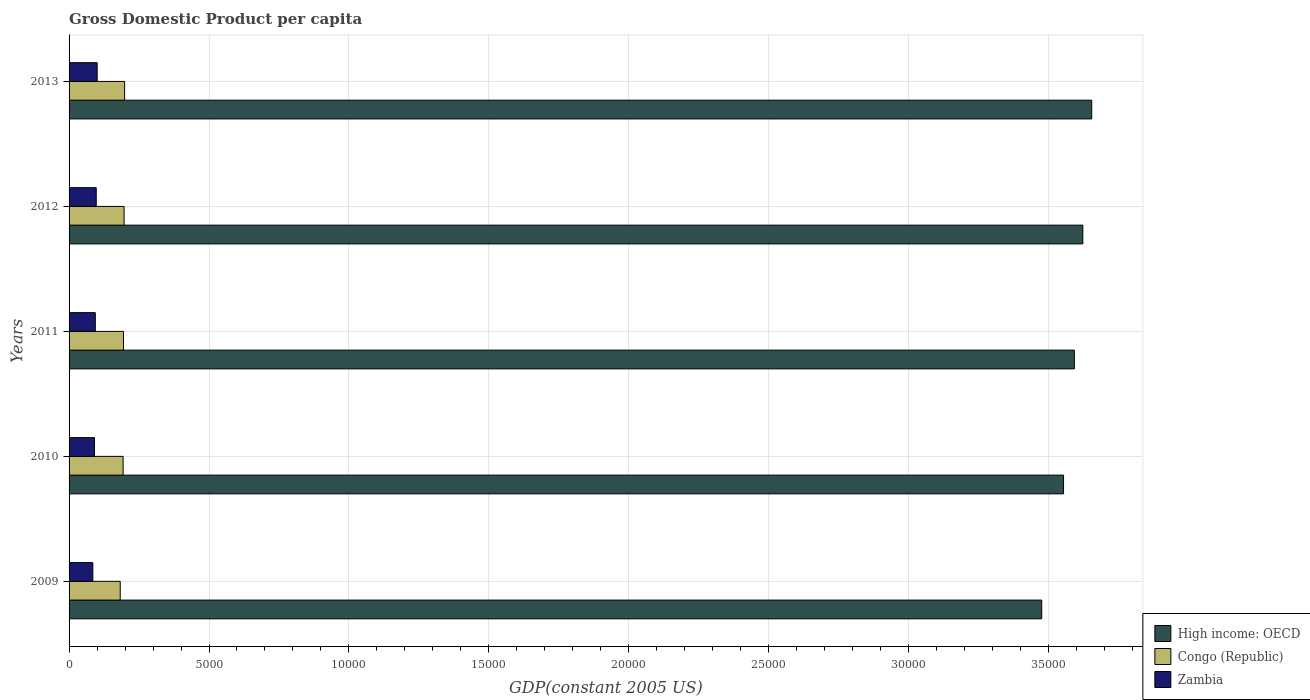How many different coloured bars are there?
Give a very brief answer. 3. How many groups of bars are there?
Keep it short and to the point. 5. Are the number of bars per tick equal to the number of legend labels?
Your answer should be compact. Yes. Are the number of bars on each tick of the Y-axis equal?
Give a very brief answer. Yes. What is the label of the 1st group of bars from the top?
Your answer should be compact. 2013. In how many cases, is the number of bars for a given year not equal to the number of legend labels?
Give a very brief answer. 0. What is the GDP per capita in Zambia in 2010?
Provide a succinct answer. 908.75. Across all years, what is the maximum GDP per capita in Congo (Republic)?
Offer a very short reply. 1984.36. Across all years, what is the minimum GDP per capita in Congo (Republic)?
Your answer should be very brief. 1827.67. In which year was the GDP per capita in Congo (Republic) maximum?
Provide a succinct answer. 2013. In which year was the GDP per capita in Zambia minimum?
Offer a very short reply. 2009. What is the total GDP per capita in High income: OECD in the graph?
Your answer should be very brief. 1.79e+05. What is the difference between the GDP per capita in Zambia in 2010 and that in 2013?
Make the answer very short. -95.97. What is the difference between the GDP per capita in High income: OECD in 2009 and the GDP per capita in Zambia in 2012?
Make the answer very short. 3.38e+04. What is the average GDP per capita in High income: OECD per year?
Provide a short and direct response. 3.58e+04. In the year 2013, what is the difference between the GDP per capita in Zambia and GDP per capita in Congo (Republic)?
Give a very brief answer. -979.64. What is the ratio of the GDP per capita in High income: OECD in 2010 to that in 2011?
Offer a terse response. 0.99. Is the difference between the GDP per capita in Zambia in 2011 and 2012 greater than the difference between the GDP per capita in Congo (Republic) in 2011 and 2012?
Your response must be concise. No. What is the difference between the highest and the second highest GDP per capita in Zambia?
Offer a terse response. 33.95. What is the difference between the highest and the lowest GDP per capita in High income: OECD?
Your answer should be compact. 1786.7. In how many years, is the GDP per capita in High income: OECD greater than the average GDP per capita in High income: OECD taken over all years?
Offer a very short reply. 3. What does the 3rd bar from the top in 2011 represents?
Your answer should be very brief. High income: OECD. What does the 1st bar from the bottom in 2011 represents?
Your answer should be compact. High income: OECD. Is it the case that in every year, the sum of the GDP per capita in High income: OECD and GDP per capita in Congo (Republic) is greater than the GDP per capita in Zambia?
Provide a short and direct response. Yes. How many bars are there?
Provide a short and direct response. 15. Are all the bars in the graph horizontal?
Your response must be concise. Yes. What is the difference between two consecutive major ticks on the X-axis?
Your response must be concise. 5000. Are the values on the major ticks of X-axis written in scientific E-notation?
Ensure brevity in your answer.  No. Does the graph contain any zero values?
Offer a terse response. No. Where does the legend appear in the graph?
Give a very brief answer. Bottom right. How many legend labels are there?
Your answer should be compact. 3. How are the legend labels stacked?
Your answer should be compact. Vertical. What is the title of the graph?
Provide a succinct answer. Gross Domestic Product per capita. What is the label or title of the X-axis?
Ensure brevity in your answer.  GDP(constant 2005 US). What is the label or title of the Y-axis?
Give a very brief answer. Years. What is the GDP(constant 2005 US) of High income: OECD in 2009?
Offer a very short reply. 3.48e+04. What is the GDP(constant 2005 US) of Congo (Republic) in 2009?
Ensure brevity in your answer.  1827.67. What is the GDP(constant 2005 US) of Zambia in 2009?
Provide a succinct answer. 848.88. What is the GDP(constant 2005 US) of High income: OECD in 2010?
Make the answer very short. 3.55e+04. What is the GDP(constant 2005 US) of Congo (Republic) in 2010?
Keep it short and to the point. 1931.26. What is the GDP(constant 2005 US) of Zambia in 2010?
Your answer should be compact. 908.75. What is the GDP(constant 2005 US) of High income: OECD in 2011?
Keep it short and to the point. 3.59e+04. What is the GDP(constant 2005 US) in Congo (Republic) in 2011?
Offer a very short reply. 1944.08. What is the GDP(constant 2005 US) of Zambia in 2011?
Provide a short and direct response. 937.64. What is the GDP(constant 2005 US) of High income: OECD in 2012?
Your answer should be compact. 3.62e+04. What is the GDP(constant 2005 US) in Congo (Republic) in 2012?
Provide a succinct answer. 1966.76. What is the GDP(constant 2005 US) of Zambia in 2012?
Give a very brief answer. 970.77. What is the GDP(constant 2005 US) in High income: OECD in 2013?
Keep it short and to the point. 3.65e+04. What is the GDP(constant 2005 US) of Congo (Republic) in 2013?
Your answer should be very brief. 1984.36. What is the GDP(constant 2005 US) in Zambia in 2013?
Your answer should be compact. 1004.71. Across all years, what is the maximum GDP(constant 2005 US) in High income: OECD?
Offer a terse response. 3.65e+04. Across all years, what is the maximum GDP(constant 2005 US) of Congo (Republic)?
Make the answer very short. 1984.36. Across all years, what is the maximum GDP(constant 2005 US) of Zambia?
Offer a terse response. 1004.71. Across all years, what is the minimum GDP(constant 2005 US) of High income: OECD?
Your answer should be compact. 3.48e+04. Across all years, what is the minimum GDP(constant 2005 US) of Congo (Republic)?
Your answer should be very brief. 1827.67. Across all years, what is the minimum GDP(constant 2005 US) of Zambia?
Provide a short and direct response. 848.88. What is the total GDP(constant 2005 US) in High income: OECD in the graph?
Provide a succinct answer. 1.79e+05. What is the total GDP(constant 2005 US) of Congo (Republic) in the graph?
Your answer should be very brief. 9654.13. What is the total GDP(constant 2005 US) of Zambia in the graph?
Provide a succinct answer. 4670.75. What is the difference between the GDP(constant 2005 US) in High income: OECD in 2009 and that in 2010?
Your answer should be very brief. -780.06. What is the difference between the GDP(constant 2005 US) of Congo (Republic) in 2009 and that in 2010?
Offer a very short reply. -103.59. What is the difference between the GDP(constant 2005 US) in Zambia in 2009 and that in 2010?
Give a very brief answer. -59.86. What is the difference between the GDP(constant 2005 US) of High income: OECD in 2009 and that in 2011?
Your answer should be very brief. -1165.33. What is the difference between the GDP(constant 2005 US) in Congo (Republic) in 2009 and that in 2011?
Your response must be concise. -116.41. What is the difference between the GDP(constant 2005 US) in Zambia in 2009 and that in 2011?
Offer a very short reply. -88.76. What is the difference between the GDP(constant 2005 US) of High income: OECD in 2009 and that in 2012?
Make the answer very short. -1469.18. What is the difference between the GDP(constant 2005 US) in Congo (Republic) in 2009 and that in 2012?
Give a very brief answer. -139.09. What is the difference between the GDP(constant 2005 US) of Zambia in 2009 and that in 2012?
Provide a succinct answer. -121.88. What is the difference between the GDP(constant 2005 US) of High income: OECD in 2009 and that in 2013?
Provide a short and direct response. -1786.7. What is the difference between the GDP(constant 2005 US) in Congo (Republic) in 2009 and that in 2013?
Offer a terse response. -156.69. What is the difference between the GDP(constant 2005 US) of Zambia in 2009 and that in 2013?
Provide a short and direct response. -155.83. What is the difference between the GDP(constant 2005 US) in High income: OECD in 2010 and that in 2011?
Make the answer very short. -385.27. What is the difference between the GDP(constant 2005 US) of Congo (Republic) in 2010 and that in 2011?
Keep it short and to the point. -12.82. What is the difference between the GDP(constant 2005 US) in Zambia in 2010 and that in 2011?
Provide a succinct answer. -28.89. What is the difference between the GDP(constant 2005 US) of High income: OECD in 2010 and that in 2012?
Offer a terse response. -689.12. What is the difference between the GDP(constant 2005 US) in Congo (Republic) in 2010 and that in 2012?
Your answer should be very brief. -35.49. What is the difference between the GDP(constant 2005 US) of Zambia in 2010 and that in 2012?
Your answer should be very brief. -62.02. What is the difference between the GDP(constant 2005 US) in High income: OECD in 2010 and that in 2013?
Provide a short and direct response. -1006.65. What is the difference between the GDP(constant 2005 US) of Congo (Republic) in 2010 and that in 2013?
Your answer should be compact. -53.09. What is the difference between the GDP(constant 2005 US) of Zambia in 2010 and that in 2013?
Your answer should be very brief. -95.97. What is the difference between the GDP(constant 2005 US) of High income: OECD in 2011 and that in 2012?
Provide a short and direct response. -303.85. What is the difference between the GDP(constant 2005 US) of Congo (Republic) in 2011 and that in 2012?
Provide a short and direct response. -22.67. What is the difference between the GDP(constant 2005 US) in Zambia in 2011 and that in 2012?
Provide a succinct answer. -33.12. What is the difference between the GDP(constant 2005 US) of High income: OECD in 2011 and that in 2013?
Offer a terse response. -621.37. What is the difference between the GDP(constant 2005 US) in Congo (Republic) in 2011 and that in 2013?
Make the answer very short. -40.28. What is the difference between the GDP(constant 2005 US) of Zambia in 2011 and that in 2013?
Provide a succinct answer. -67.07. What is the difference between the GDP(constant 2005 US) in High income: OECD in 2012 and that in 2013?
Provide a succinct answer. -317.52. What is the difference between the GDP(constant 2005 US) of Congo (Republic) in 2012 and that in 2013?
Provide a succinct answer. -17.6. What is the difference between the GDP(constant 2005 US) in Zambia in 2012 and that in 2013?
Provide a succinct answer. -33.95. What is the difference between the GDP(constant 2005 US) in High income: OECD in 2009 and the GDP(constant 2005 US) in Congo (Republic) in 2010?
Your answer should be compact. 3.28e+04. What is the difference between the GDP(constant 2005 US) of High income: OECD in 2009 and the GDP(constant 2005 US) of Zambia in 2010?
Provide a short and direct response. 3.38e+04. What is the difference between the GDP(constant 2005 US) in Congo (Republic) in 2009 and the GDP(constant 2005 US) in Zambia in 2010?
Ensure brevity in your answer.  918.92. What is the difference between the GDP(constant 2005 US) in High income: OECD in 2009 and the GDP(constant 2005 US) in Congo (Republic) in 2011?
Provide a short and direct response. 3.28e+04. What is the difference between the GDP(constant 2005 US) in High income: OECD in 2009 and the GDP(constant 2005 US) in Zambia in 2011?
Make the answer very short. 3.38e+04. What is the difference between the GDP(constant 2005 US) of Congo (Republic) in 2009 and the GDP(constant 2005 US) of Zambia in 2011?
Offer a terse response. 890.03. What is the difference between the GDP(constant 2005 US) of High income: OECD in 2009 and the GDP(constant 2005 US) of Congo (Republic) in 2012?
Your answer should be very brief. 3.28e+04. What is the difference between the GDP(constant 2005 US) of High income: OECD in 2009 and the GDP(constant 2005 US) of Zambia in 2012?
Offer a terse response. 3.38e+04. What is the difference between the GDP(constant 2005 US) in Congo (Republic) in 2009 and the GDP(constant 2005 US) in Zambia in 2012?
Offer a terse response. 856.9. What is the difference between the GDP(constant 2005 US) in High income: OECD in 2009 and the GDP(constant 2005 US) in Congo (Republic) in 2013?
Your answer should be compact. 3.28e+04. What is the difference between the GDP(constant 2005 US) in High income: OECD in 2009 and the GDP(constant 2005 US) in Zambia in 2013?
Your response must be concise. 3.37e+04. What is the difference between the GDP(constant 2005 US) in Congo (Republic) in 2009 and the GDP(constant 2005 US) in Zambia in 2013?
Make the answer very short. 822.96. What is the difference between the GDP(constant 2005 US) of High income: OECD in 2010 and the GDP(constant 2005 US) of Congo (Republic) in 2011?
Your answer should be compact. 3.36e+04. What is the difference between the GDP(constant 2005 US) in High income: OECD in 2010 and the GDP(constant 2005 US) in Zambia in 2011?
Offer a terse response. 3.46e+04. What is the difference between the GDP(constant 2005 US) of Congo (Republic) in 2010 and the GDP(constant 2005 US) of Zambia in 2011?
Your answer should be very brief. 993.62. What is the difference between the GDP(constant 2005 US) in High income: OECD in 2010 and the GDP(constant 2005 US) in Congo (Republic) in 2012?
Your answer should be very brief. 3.36e+04. What is the difference between the GDP(constant 2005 US) in High income: OECD in 2010 and the GDP(constant 2005 US) in Zambia in 2012?
Your answer should be compact. 3.46e+04. What is the difference between the GDP(constant 2005 US) in Congo (Republic) in 2010 and the GDP(constant 2005 US) in Zambia in 2012?
Make the answer very short. 960.5. What is the difference between the GDP(constant 2005 US) of High income: OECD in 2010 and the GDP(constant 2005 US) of Congo (Republic) in 2013?
Offer a very short reply. 3.35e+04. What is the difference between the GDP(constant 2005 US) of High income: OECD in 2010 and the GDP(constant 2005 US) of Zambia in 2013?
Make the answer very short. 3.45e+04. What is the difference between the GDP(constant 2005 US) of Congo (Republic) in 2010 and the GDP(constant 2005 US) of Zambia in 2013?
Offer a terse response. 926.55. What is the difference between the GDP(constant 2005 US) in High income: OECD in 2011 and the GDP(constant 2005 US) in Congo (Republic) in 2012?
Keep it short and to the point. 3.40e+04. What is the difference between the GDP(constant 2005 US) of High income: OECD in 2011 and the GDP(constant 2005 US) of Zambia in 2012?
Your answer should be very brief. 3.49e+04. What is the difference between the GDP(constant 2005 US) in Congo (Republic) in 2011 and the GDP(constant 2005 US) in Zambia in 2012?
Give a very brief answer. 973.32. What is the difference between the GDP(constant 2005 US) in High income: OECD in 2011 and the GDP(constant 2005 US) in Congo (Republic) in 2013?
Give a very brief answer. 3.39e+04. What is the difference between the GDP(constant 2005 US) in High income: OECD in 2011 and the GDP(constant 2005 US) in Zambia in 2013?
Keep it short and to the point. 3.49e+04. What is the difference between the GDP(constant 2005 US) in Congo (Republic) in 2011 and the GDP(constant 2005 US) in Zambia in 2013?
Offer a very short reply. 939.37. What is the difference between the GDP(constant 2005 US) in High income: OECD in 2012 and the GDP(constant 2005 US) in Congo (Republic) in 2013?
Offer a terse response. 3.42e+04. What is the difference between the GDP(constant 2005 US) of High income: OECD in 2012 and the GDP(constant 2005 US) of Zambia in 2013?
Provide a succinct answer. 3.52e+04. What is the difference between the GDP(constant 2005 US) in Congo (Republic) in 2012 and the GDP(constant 2005 US) in Zambia in 2013?
Provide a succinct answer. 962.04. What is the average GDP(constant 2005 US) of High income: OECD per year?
Make the answer very short. 3.58e+04. What is the average GDP(constant 2005 US) in Congo (Republic) per year?
Offer a terse response. 1930.83. What is the average GDP(constant 2005 US) of Zambia per year?
Provide a short and direct response. 934.15. In the year 2009, what is the difference between the GDP(constant 2005 US) of High income: OECD and GDP(constant 2005 US) of Congo (Republic)?
Provide a succinct answer. 3.29e+04. In the year 2009, what is the difference between the GDP(constant 2005 US) in High income: OECD and GDP(constant 2005 US) in Zambia?
Your answer should be very brief. 3.39e+04. In the year 2009, what is the difference between the GDP(constant 2005 US) of Congo (Republic) and GDP(constant 2005 US) of Zambia?
Your answer should be compact. 978.79. In the year 2010, what is the difference between the GDP(constant 2005 US) of High income: OECD and GDP(constant 2005 US) of Congo (Republic)?
Offer a terse response. 3.36e+04. In the year 2010, what is the difference between the GDP(constant 2005 US) in High income: OECD and GDP(constant 2005 US) in Zambia?
Ensure brevity in your answer.  3.46e+04. In the year 2010, what is the difference between the GDP(constant 2005 US) of Congo (Republic) and GDP(constant 2005 US) of Zambia?
Offer a terse response. 1022.52. In the year 2011, what is the difference between the GDP(constant 2005 US) of High income: OECD and GDP(constant 2005 US) of Congo (Republic)?
Give a very brief answer. 3.40e+04. In the year 2011, what is the difference between the GDP(constant 2005 US) in High income: OECD and GDP(constant 2005 US) in Zambia?
Your response must be concise. 3.50e+04. In the year 2011, what is the difference between the GDP(constant 2005 US) of Congo (Republic) and GDP(constant 2005 US) of Zambia?
Offer a very short reply. 1006.44. In the year 2012, what is the difference between the GDP(constant 2005 US) of High income: OECD and GDP(constant 2005 US) of Congo (Republic)?
Your answer should be very brief. 3.43e+04. In the year 2012, what is the difference between the GDP(constant 2005 US) of High income: OECD and GDP(constant 2005 US) of Zambia?
Offer a terse response. 3.53e+04. In the year 2012, what is the difference between the GDP(constant 2005 US) of Congo (Republic) and GDP(constant 2005 US) of Zambia?
Provide a short and direct response. 995.99. In the year 2013, what is the difference between the GDP(constant 2005 US) of High income: OECD and GDP(constant 2005 US) of Congo (Republic)?
Ensure brevity in your answer.  3.46e+04. In the year 2013, what is the difference between the GDP(constant 2005 US) in High income: OECD and GDP(constant 2005 US) in Zambia?
Give a very brief answer. 3.55e+04. In the year 2013, what is the difference between the GDP(constant 2005 US) in Congo (Republic) and GDP(constant 2005 US) in Zambia?
Give a very brief answer. 979.64. What is the ratio of the GDP(constant 2005 US) of Congo (Republic) in 2009 to that in 2010?
Keep it short and to the point. 0.95. What is the ratio of the GDP(constant 2005 US) in Zambia in 2009 to that in 2010?
Offer a very short reply. 0.93. What is the ratio of the GDP(constant 2005 US) in High income: OECD in 2009 to that in 2011?
Give a very brief answer. 0.97. What is the ratio of the GDP(constant 2005 US) of Congo (Republic) in 2009 to that in 2011?
Offer a terse response. 0.94. What is the ratio of the GDP(constant 2005 US) of Zambia in 2009 to that in 2011?
Give a very brief answer. 0.91. What is the ratio of the GDP(constant 2005 US) of High income: OECD in 2009 to that in 2012?
Provide a short and direct response. 0.96. What is the ratio of the GDP(constant 2005 US) of Congo (Republic) in 2009 to that in 2012?
Your answer should be very brief. 0.93. What is the ratio of the GDP(constant 2005 US) of Zambia in 2009 to that in 2012?
Ensure brevity in your answer.  0.87. What is the ratio of the GDP(constant 2005 US) of High income: OECD in 2009 to that in 2013?
Provide a short and direct response. 0.95. What is the ratio of the GDP(constant 2005 US) in Congo (Republic) in 2009 to that in 2013?
Keep it short and to the point. 0.92. What is the ratio of the GDP(constant 2005 US) in Zambia in 2009 to that in 2013?
Offer a very short reply. 0.84. What is the ratio of the GDP(constant 2005 US) of High income: OECD in 2010 to that in 2011?
Ensure brevity in your answer.  0.99. What is the ratio of the GDP(constant 2005 US) in Zambia in 2010 to that in 2011?
Offer a very short reply. 0.97. What is the ratio of the GDP(constant 2005 US) of High income: OECD in 2010 to that in 2012?
Your answer should be compact. 0.98. What is the ratio of the GDP(constant 2005 US) of Zambia in 2010 to that in 2012?
Give a very brief answer. 0.94. What is the ratio of the GDP(constant 2005 US) of High income: OECD in 2010 to that in 2013?
Provide a short and direct response. 0.97. What is the ratio of the GDP(constant 2005 US) in Congo (Republic) in 2010 to that in 2013?
Give a very brief answer. 0.97. What is the ratio of the GDP(constant 2005 US) of Zambia in 2010 to that in 2013?
Keep it short and to the point. 0.9. What is the ratio of the GDP(constant 2005 US) in Congo (Republic) in 2011 to that in 2012?
Give a very brief answer. 0.99. What is the ratio of the GDP(constant 2005 US) of Zambia in 2011 to that in 2012?
Your response must be concise. 0.97. What is the ratio of the GDP(constant 2005 US) of High income: OECD in 2011 to that in 2013?
Offer a terse response. 0.98. What is the ratio of the GDP(constant 2005 US) of Congo (Republic) in 2011 to that in 2013?
Give a very brief answer. 0.98. What is the ratio of the GDP(constant 2005 US) in Zambia in 2011 to that in 2013?
Provide a succinct answer. 0.93. What is the ratio of the GDP(constant 2005 US) of Congo (Republic) in 2012 to that in 2013?
Your answer should be compact. 0.99. What is the ratio of the GDP(constant 2005 US) in Zambia in 2012 to that in 2013?
Provide a succinct answer. 0.97. What is the difference between the highest and the second highest GDP(constant 2005 US) in High income: OECD?
Your answer should be very brief. 317.52. What is the difference between the highest and the second highest GDP(constant 2005 US) of Congo (Republic)?
Offer a terse response. 17.6. What is the difference between the highest and the second highest GDP(constant 2005 US) in Zambia?
Keep it short and to the point. 33.95. What is the difference between the highest and the lowest GDP(constant 2005 US) of High income: OECD?
Your answer should be very brief. 1786.7. What is the difference between the highest and the lowest GDP(constant 2005 US) of Congo (Republic)?
Make the answer very short. 156.69. What is the difference between the highest and the lowest GDP(constant 2005 US) in Zambia?
Give a very brief answer. 155.83. 